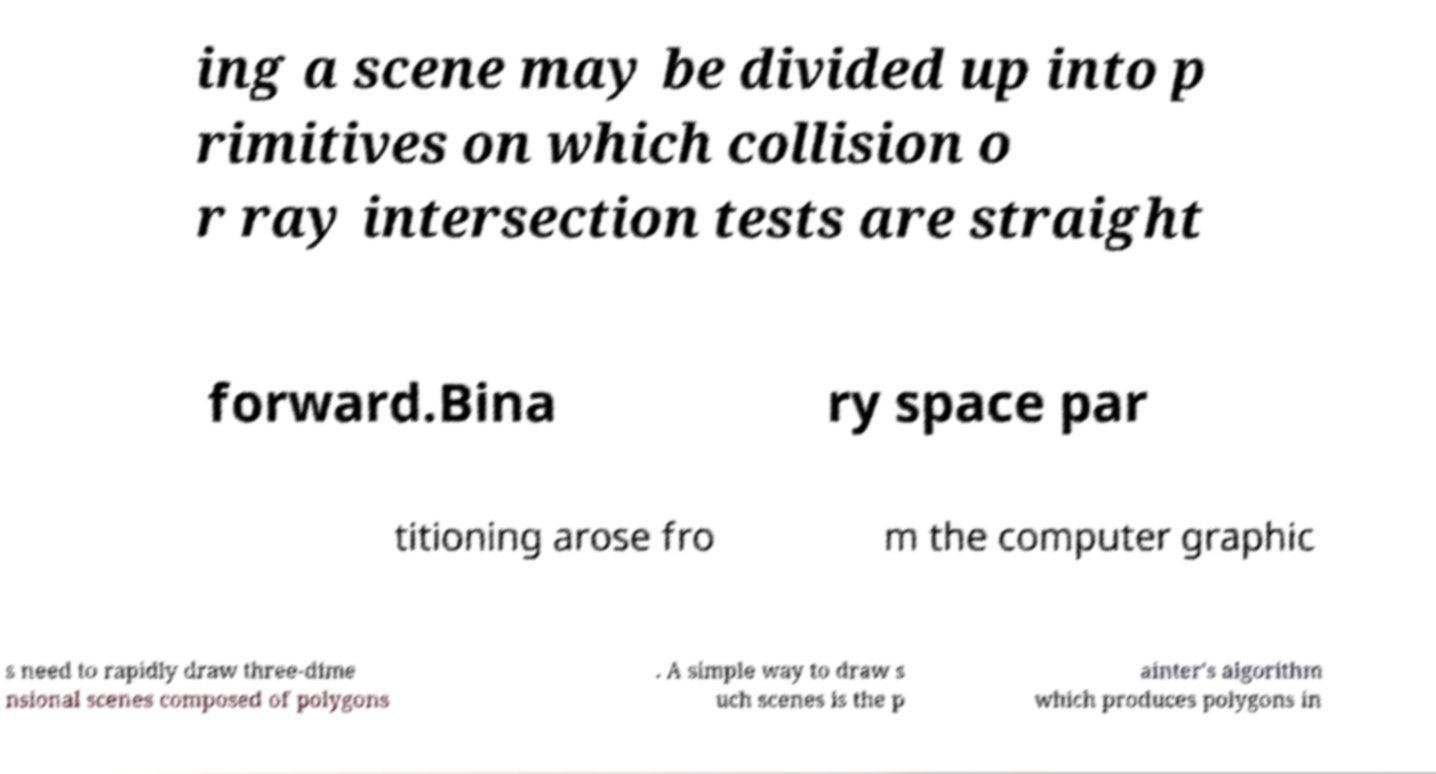Could you assist in decoding the text presented in this image and type it out clearly? ing a scene may be divided up into p rimitives on which collision o r ray intersection tests are straight forward.Bina ry space par titioning arose fro m the computer graphic s need to rapidly draw three-dime nsional scenes composed of polygons . A simple way to draw s uch scenes is the p ainter's algorithm which produces polygons in 